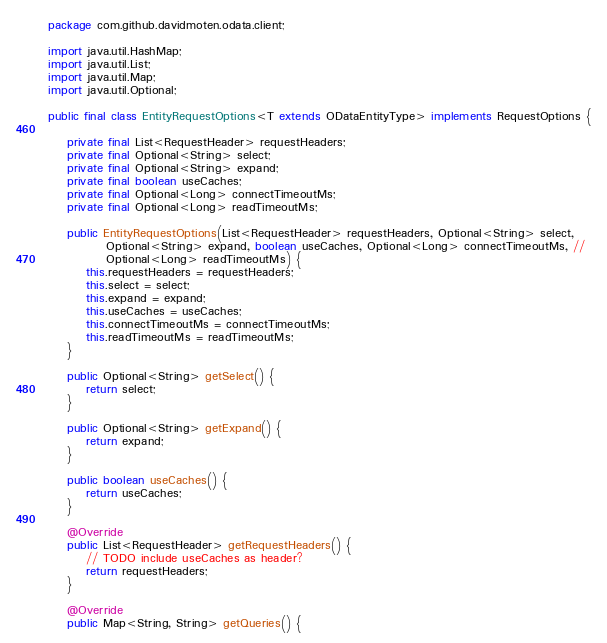Convert code to text. <code><loc_0><loc_0><loc_500><loc_500><_Java_>package com.github.davidmoten.odata.client;

import java.util.HashMap;
import java.util.List;
import java.util.Map;
import java.util.Optional;

public final class EntityRequestOptions<T extends ODataEntityType> implements RequestOptions {

    private final List<RequestHeader> requestHeaders;
    private final Optional<String> select;
    private final Optional<String> expand;
    private final boolean useCaches;
	private final Optional<Long> connectTimeoutMs;
	private final Optional<Long> readTimeoutMs;

    public EntityRequestOptions(List<RequestHeader> requestHeaders, Optional<String> select,
            Optional<String> expand, boolean useCaches, Optional<Long> connectTimeoutMs, //
            Optional<Long> readTimeoutMs) {
        this.requestHeaders = requestHeaders;
        this.select = select;
        this.expand = expand;
        this.useCaches = useCaches;
        this.connectTimeoutMs = connectTimeoutMs;
        this.readTimeoutMs = readTimeoutMs;
    }

    public Optional<String> getSelect() {
        return select;
    }

    public Optional<String> getExpand() {
        return expand;
    }

    public boolean useCaches() {
        return useCaches;
    }

    @Override
    public List<RequestHeader> getRequestHeaders() {
        // TODO include useCaches as header?
        return requestHeaders;
    }

    @Override
    public Map<String, String> getQueries() {</code> 